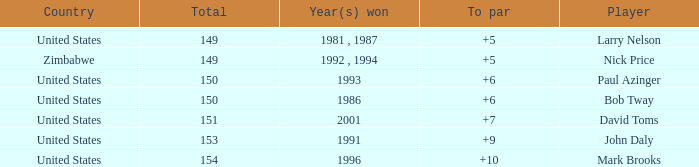How many to pars were won in 1993? 1.0. 